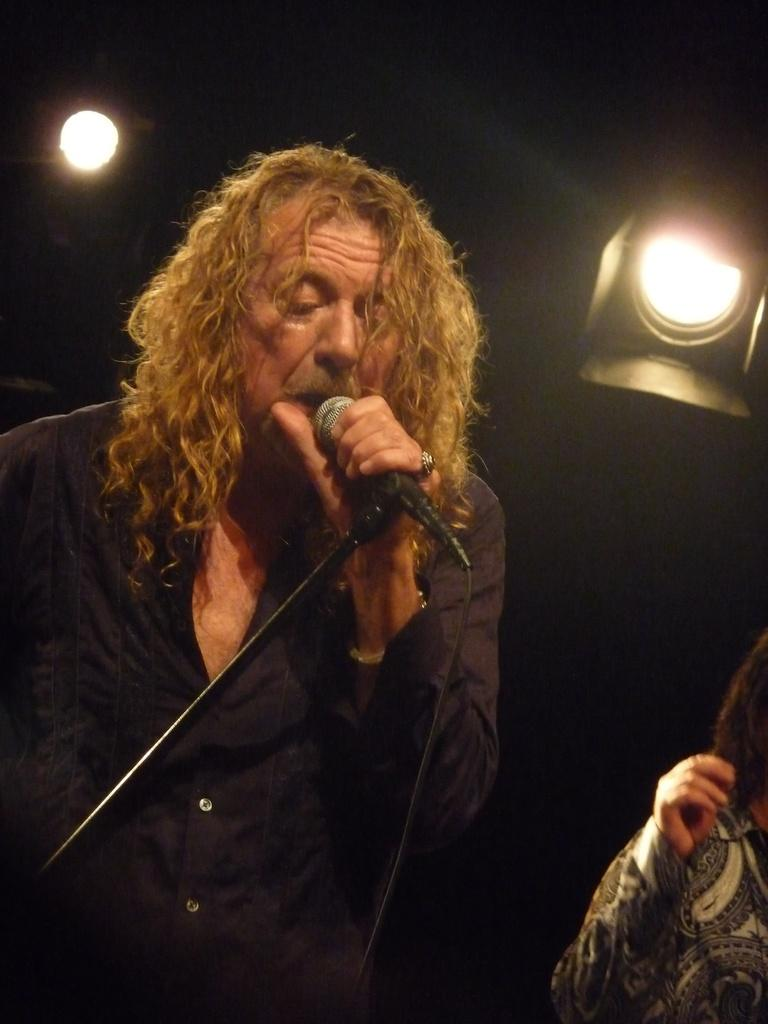What is the man in the image holding in his hand? The man is holding a microphone in his hand. How is the microphone positioned in the image? The microphone is on a stand. What can be seen in the background of the image? There are lights in the background. How would you describe the overall lighting in the image? The image is dark. Can you identify another person in the image? Yes, there is a person on the right side of the image. What type of car is the creator driving in the image? There is no car or creator present in the image. What role does the army play in the image? There is no mention of the army in the image. 